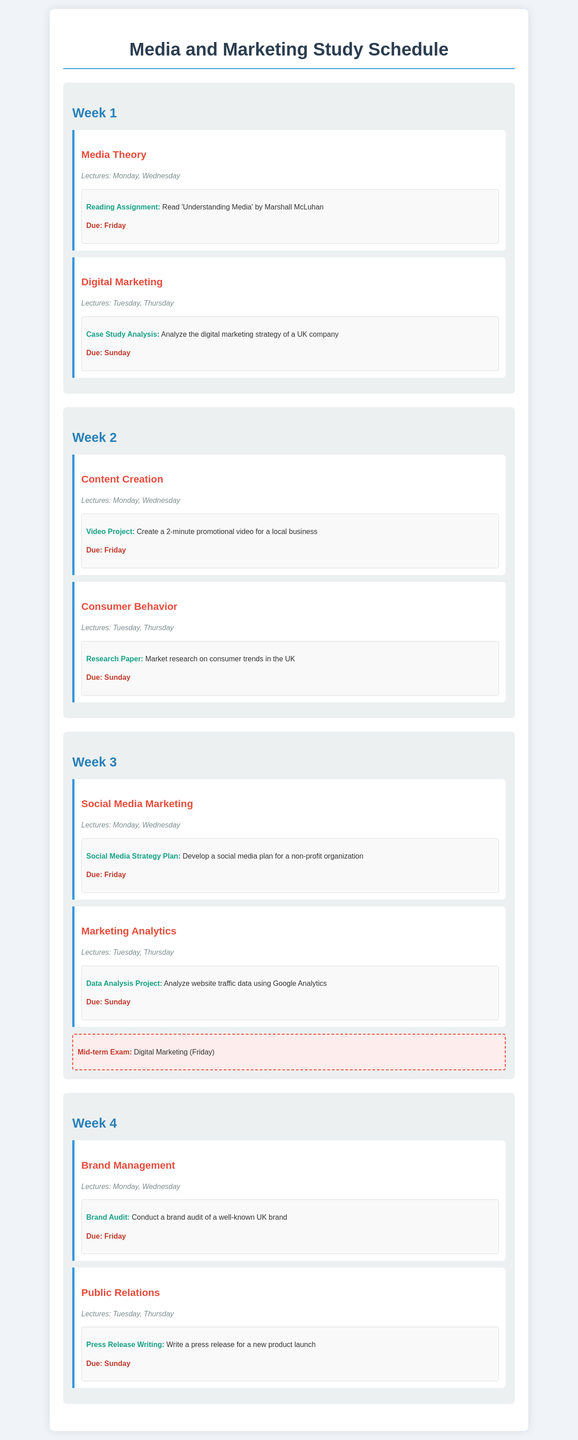What is the reading assignment due in Week 1? The reading assignment for Week 1 is specified in the document under the Media Theory module.
Answer: Read 'Understanding Media' by Marshall McLuhan Which module has lectures on Tuesday and Thursday in Week 2? The document lists the modules along with their corresponding lecture days for each week.
Answer: Digital Marketing What is the due date for the video project in Week 2? The due date for the video project is provided in the Content Creation module of Week 2.
Answer: Friday What type of project is due in Week 3 for Marketing Analytics? The document contains details about different assignments due each week for each module, including Marketing Analytics in Week 3.
Answer: Data Analysis Project When is the Mid-term Exam scheduled? The document specifies the exam details, including the Mid-term Exam date and subject.
Answer: Friday What is the topic of the assignment due on Sunday in Week 4? The assignments due on Sunday are detailed in the Public Relations module under Week 4.
Answer: Press Release Writing How many modules are covered in Week 3? The document lists the modules for each week, allowing for the counting of modules in Week 3.
Answer: 2 What is the title of the video project assignment in Week 2? The specific titles of assignments are mentioned under the respective modules, including Content Creation in Week 2.
Answer: Video Project Which day of the week are lectures for Media Theory conducted? The document includes the lecture days for each module, including Media Theory.
Answer: Monday, Wednesday 